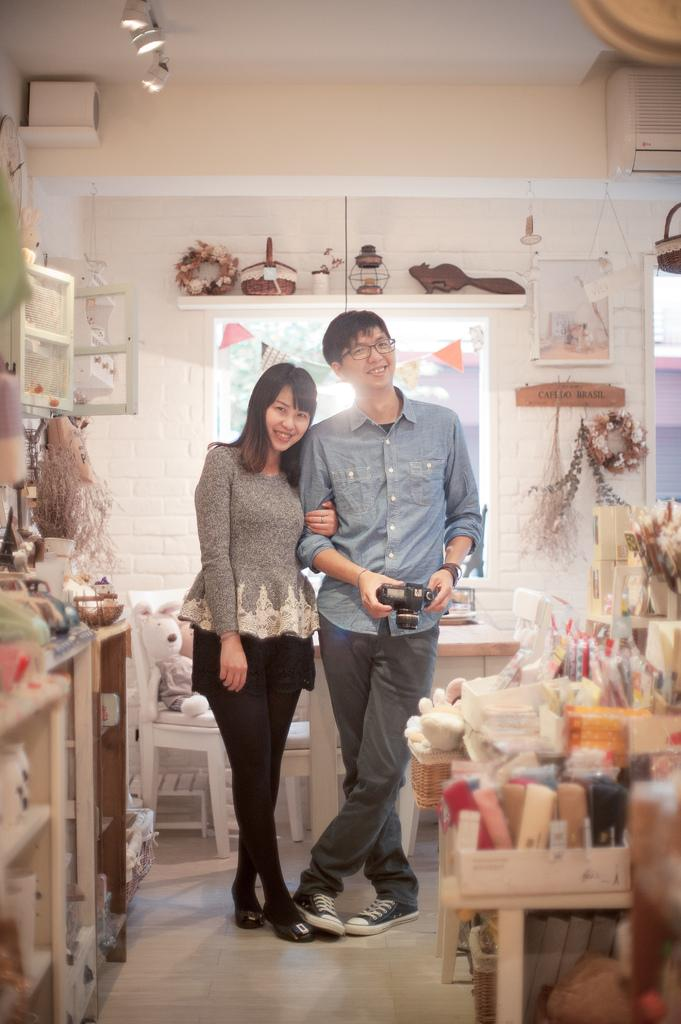Who is present in the image? There is a couple in the image. What are the couple doing in the image? The couple is posing for a camera. What is the man holding in his hand? The man is holding a camera in his hand. What type of trade is being conducted between the couple in the image? There is no indication of any trade being conducted between the couple in the image. What is the air quality like in the image? The image does not provide any information about the air quality. 